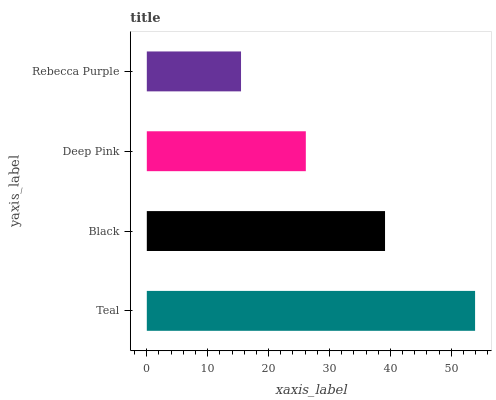Is Rebecca Purple the minimum?
Answer yes or no. Yes. Is Teal the maximum?
Answer yes or no. Yes. Is Black the minimum?
Answer yes or no. No. Is Black the maximum?
Answer yes or no. No. Is Teal greater than Black?
Answer yes or no. Yes. Is Black less than Teal?
Answer yes or no. Yes. Is Black greater than Teal?
Answer yes or no. No. Is Teal less than Black?
Answer yes or no. No. Is Black the high median?
Answer yes or no. Yes. Is Deep Pink the low median?
Answer yes or no. Yes. Is Rebecca Purple the high median?
Answer yes or no. No. Is Teal the low median?
Answer yes or no. No. 